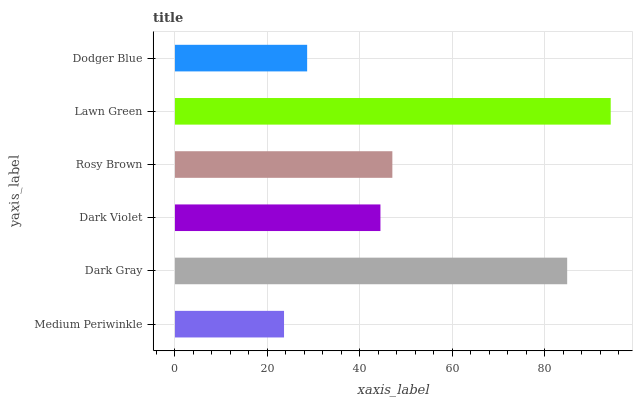Is Medium Periwinkle the minimum?
Answer yes or no. Yes. Is Lawn Green the maximum?
Answer yes or no. Yes. Is Dark Gray the minimum?
Answer yes or no. No. Is Dark Gray the maximum?
Answer yes or no. No. Is Dark Gray greater than Medium Periwinkle?
Answer yes or no. Yes. Is Medium Periwinkle less than Dark Gray?
Answer yes or no. Yes. Is Medium Periwinkle greater than Dark Gray?
Answer yes or no. No. Is Dark Gray less than Medium Periwinkle?
Answer yes or no. No. Is Rosy Brown the high median?
Answer yes or no. Yes. Is Dark Violet the low median?
Answer yes or no. Yes. Is Dodger Blue the high median?
Answer yes or no. No. Is Lawn Green the low median?
Answer yes or no. No. 